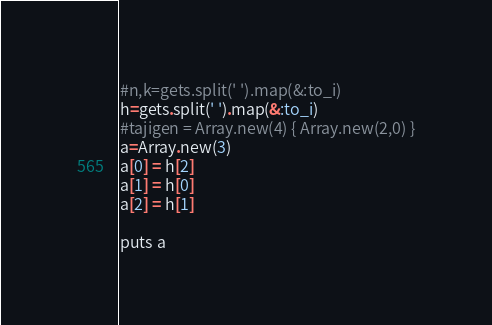Convert code to text. <code><loc_0><loc_0><loc_500><loc_500><_Ruby_>#n,k=gets.split(' ').map(&:to_i)
h=gets.split(' ').map(&:to_i)
#tajigen = Array.new(4) { Array.new(2,0) }
a=Array.new(3)
a[0] = h[2]
a[1] = h[0]
a[2] = h[1]

puts a
</code> 